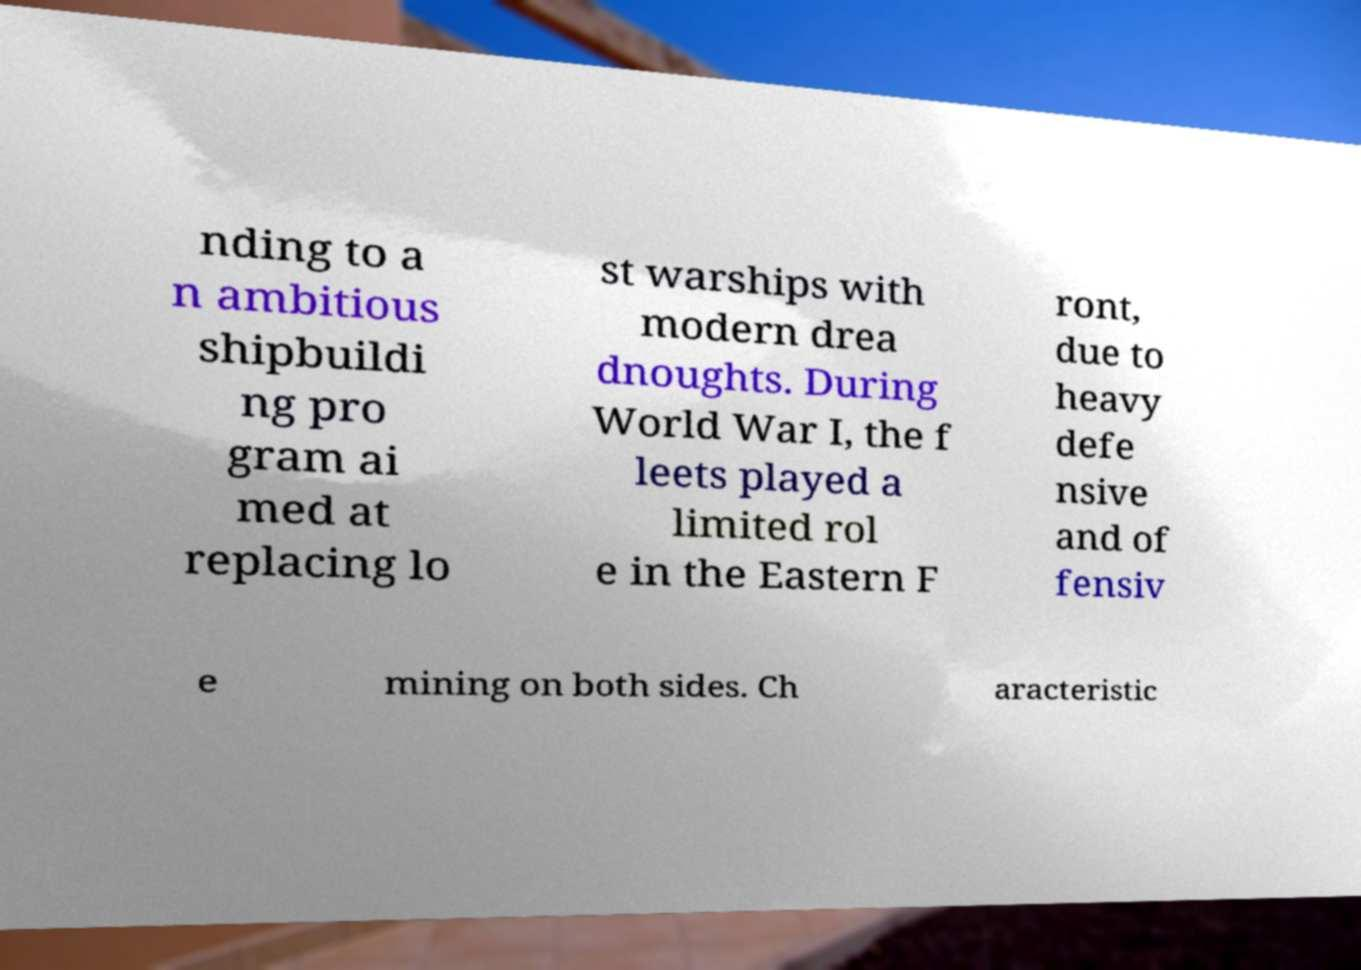For documentation purposes, I need the text within this image transcribed. Could you provide that? nding to a n ambitious shipbuildi ng pro gram ai med at replacing lo st warships with modern drea dnoughts. During World War I, the f leets played a limited rol e in the Eastern F ront, due to heavy defe nsive and of fensiv e mining on both sides. Ch aracteristic 